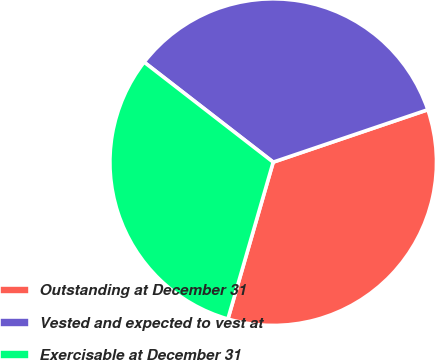Convert chart to OTSL. <chart><loc_0><loc_0><loc_500><loc_500><pie_chart><fcel>Outstanding at December 31<fcel>Vested and expected to vest at<fcel>Exercisable at December 31<nl><fcel>34.68%<fcel>34.31%<fcel>31.02%<nl></chart> 